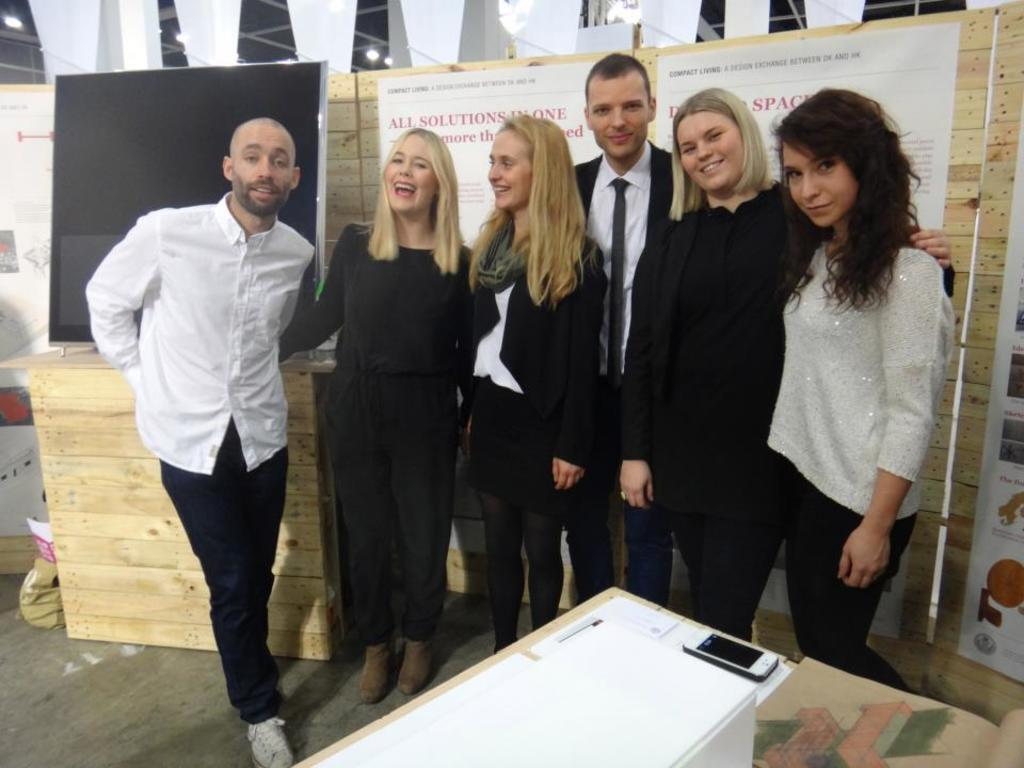Who or what is present in the image? There are people in the image. What is the facial expression of the people in the image? The people are smiling. What object can be seen on a table in the image? There is a mobile on a table in front of the people. What type of material is visible in the background of the image? There are wooden boards visible in the background. What type of brass instrument is being played by the people in the image? There is no brass instrument present in the image; the people are simply smiling. Can you tell me how many snails are crawling on the table in the image? There are no snails present in the image; the table only has a mobile on it. 